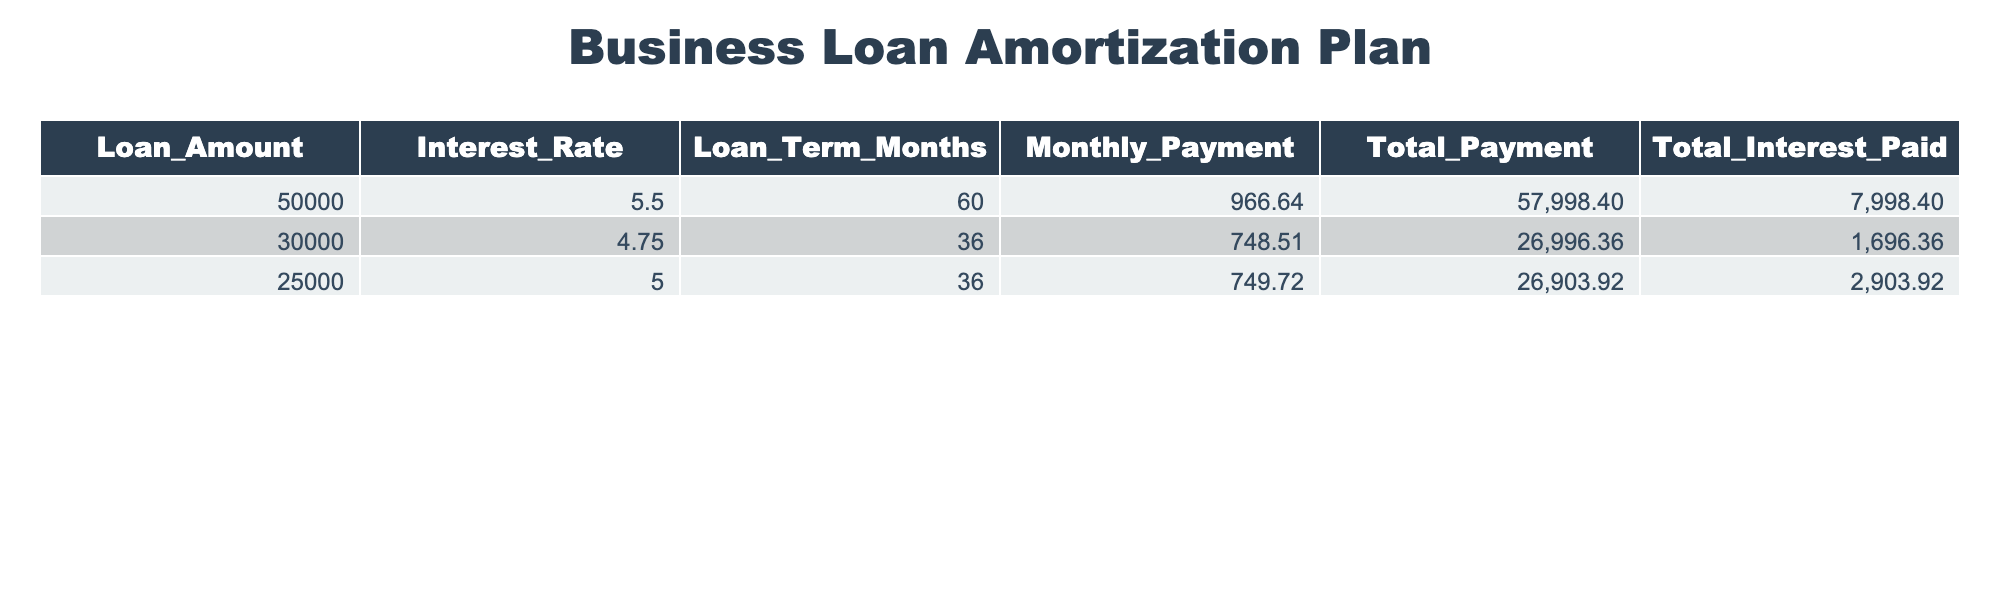What is the Monthly Payment for the $50,000 loan? The Monthly Payment for the $50,000 loan is directly provided in the table under the corresponding column, which shows the value 966.64.
Answer: 966.64 What is the Total Interest Paid on the $30,000 loan? The Total Interest Paid on the $30,000 loan is stated in the table, which lists it as 1696.36.
Answer: 1696.36 Which loan has the lowest Total Payment? To find the loan with the lowest Total Payment, compare the Total Payment values for each loan: 57998.40, 26996.36, and 26903.92. The lowest is 26996.36 for the $30,000 loan.
Answer: $30,000 loan What is the average interest rate of all loans? To calculate the average interest rate, add the interest rates together (5.5 + 4.75 + 5.0 = 15.25) and divide by the number of loans (3). Therefore, the average interest rate is 15.25 / 3 = 5.0833, which rounds to approximately 5.08.
Answer: 5.08 Is the Total Payment for the $25,000 loan more than $26,000? The table shows that the Total Payment for the $25,000 loan is listed as 26903.92, which is indeed more than 26,000.
Answer: Yes Which loan has the longest term, and what is that term? To identify the loan with the longest term, we look at the Loan Term Months for each loan: 60 for the $50,000 loan, and 36 for both the $30,000 and $25,000 loans. Since 60 is greater than 36, the $50,000 loan has the longest term of 60 months.
Answer: $50,000 loan, 60 months What is the difference in Total Interest Paid between the $30,000 and $25,000 loans? The Total Interest Paid for the $30,000 loan is 1696.36, and for the $25,000 loan, it is 2903.92. To find the difference, subtract the interest of the $30,000 loan from that of the $25,000 loan (2903.92 - 1696.36 = 1207.56).
Answer: 1207.56 Is the Monthly Payment for the $30,000 loan higher than the Monthly Payment for the $50,000 loan? The Monthly Payment for the $30,000 loan is 748.51, while the Monthly Payment for the $50,000 loan is 966.64. Since 748.51 is less than 966.64, it is incorrect.
Answer: No What is the Total Payment for all loans combined? The Total Payments for all loans are listed as 57998.40 for the $50,000 loan, 26996.36 for the $30,000 loan, and 26903.92 for the $25,000 loan. Adding these amounts together gives 57998.40 + 26996.36 + 26903.92 = 111898.68.
Answer: 111898.68 